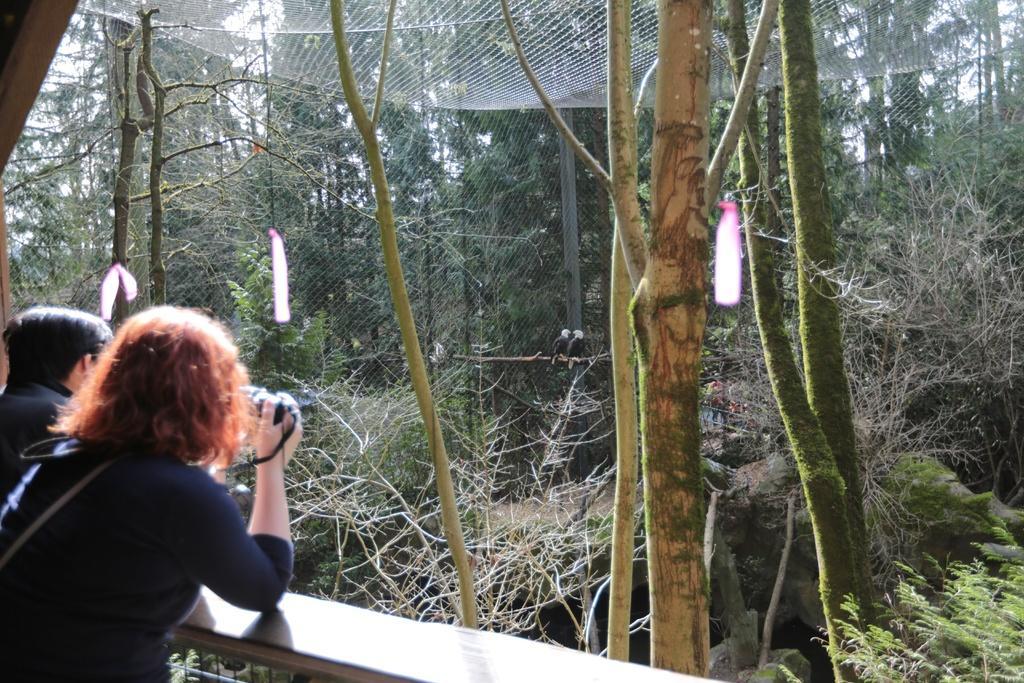Could you give a brief overview of what you see in this image? In this image, we can see people and one of them is holding an object. In the background, there are trees and we can see a net. At the bottom, there is wood. 